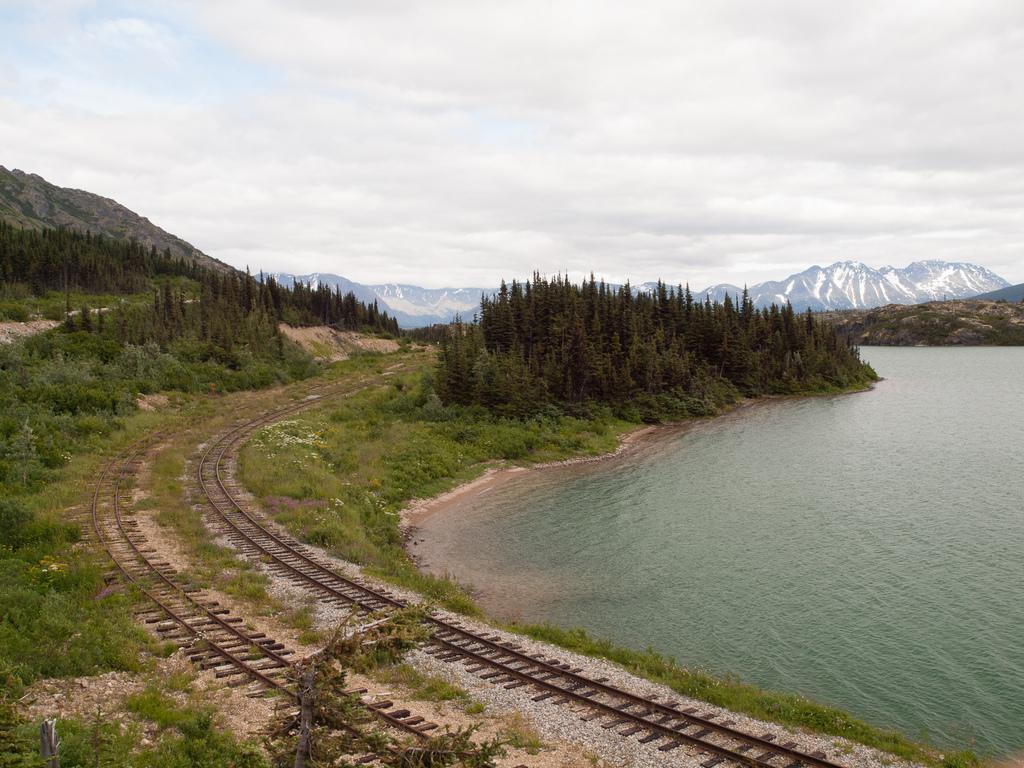Describe this image in one or two sentences. In this image we can see the railway track, there are some plants, trees, mountains and water, in the background, we can see the sky with clouds. 